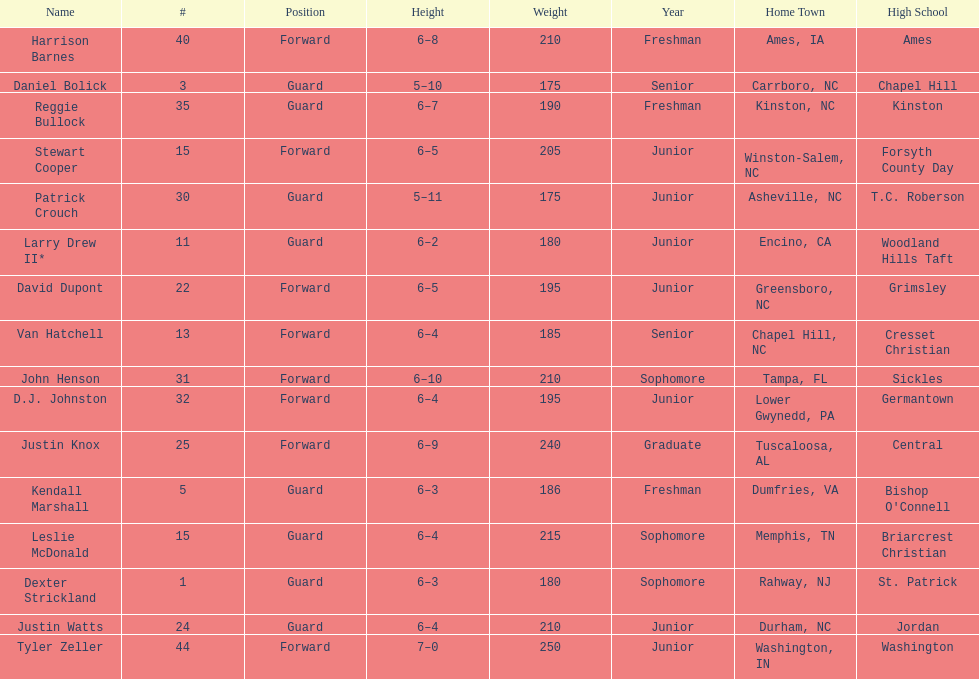Who had a greater height, justin knox or john henson? John Henson. 